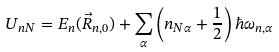<formula> <loc_0><loc_0><loc_500><loc_500>U _ { n N } = E _ { n } ( \vec { R } _ { n , 0 } ) + \sum _ { \alpha } \left ( n _ { N \alpha } + \frac { 1 } { 2 } \right ) \hbar { \omega } _ { n , \alpha }</formula> 